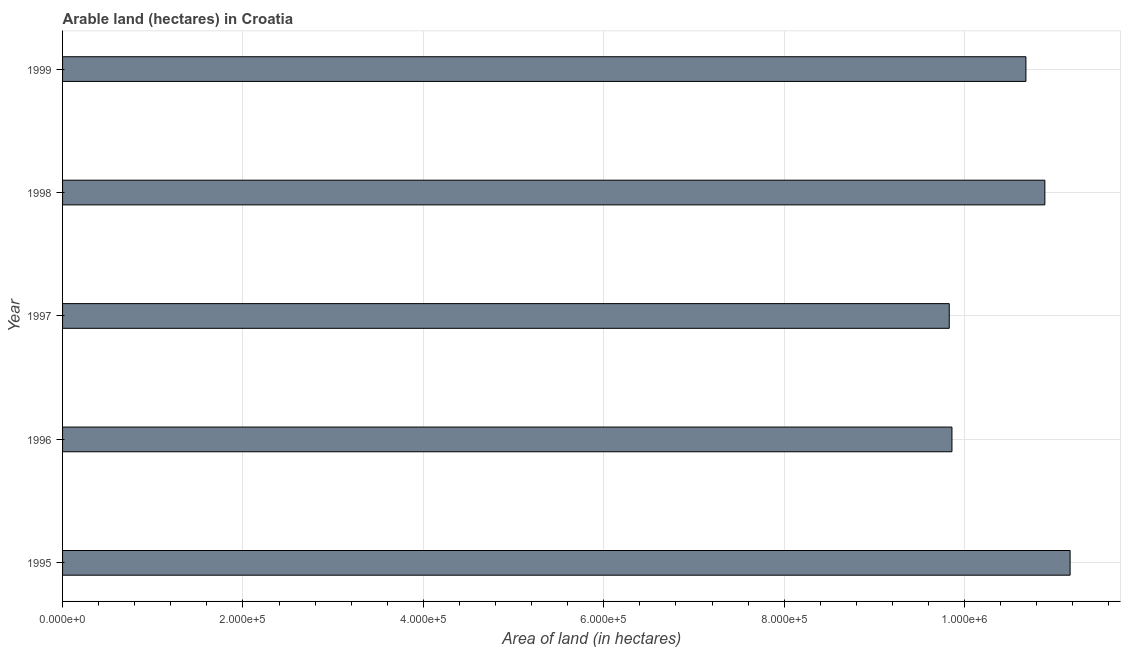What is the title of the graph?
Offer a very short reply. Arable land (hectares) in Croatia. What is the label or title of the X-axis?
Your response must be concise. Area of land (in hectares). What is the label or title of the Y-axis?
Your answer should be compact. Year. What is the area of land in 1995?
Provide a succinct answer. 1.12e+06. Across all years, what is the maximum area of land?
Provide a succinct answer. 1.12e+06. Across all years, what is the minimum area of land?
Give a very brief answer. 9.83e+05. In which year was the area of land maximum?
Your answer should be very brief. 1995. In which year was the area of land minimum?
Offer a very short reply. 1997. What is the sum of the area of land?
Provide a short and direct response. 5.24e+06. What is the difference between the area of land in 1996 and 1998?
Give a very brief answer. -1.03e+05. What is the average area of land per year?
Provide a short and direct response. 1.05e+06. What is the median area of land?
Keep it short and to the point. 1.07e+06. In how many years, is the area of land greater than 760000 hectares?
Provide a succinct answer. 5. What is the ratio of the area of land in 1995 to that in 1999?
Your answer should be compact. 1.05. Is the difference between the area of land in 1995 and 1999 greater than the difference between any two years?
Offer a very short reply. No. What is the difference between the highest and the second highest area of land?
Your response must be concise. 2.80e+04. Is the sum of the area of land in 1997 and 1999 greater than the maximum area of land across all years?
Provide a short and direct response. Yes. What is the difference between the highest and the lowest area of land?
Provide a succinct answer. 1.34e+05. In how many years, is the area of land greater than the average area of land taken over all years?
Offer a very short reply. 3. Are all the bars in the graph horizontal?
Your answer should be compact. Yes. What is the difference between two consecutive major ticks on the X-axis?
Make the answer very short. 2.00e+05. What is the Area of land (in hectares) in 1995?
Ensure brevity in your answer.  1.12e+06. What is the Area of land (in hectares) of 1996?
Provide a short and direct response. 9.86e+05. What is the Area of land (in hectares) of 1997?
Your response must be concise. 9.83e+05. What is the Area of land (in hectares) of 1998?
Your response must be concise. 1.09e+06. What is the Area of land (in hectares) of 1999?
Offer a very short reply. 1.07e+06. What is the difference between the Area of land (in hectares) in 1995 and 1996?
Offer a very short reply. 1.31e+05. What is the difference between the Area of land (in hectares) in 1995 and 1997?
Ensure brevity in your answer.  1.34e+05. What is the difference between the Area of land (in hectares) in 1995 and 1998?
Your answer should be very brief. 2.80e+04. What is the difference between the Area of land (in hectares) in 1995 and 1999?
Your answer should be compact. 4.90e+04. What is the difference between the Area of land (in hectares) in 1996 and 1997?
Ensure brevity in your answer.  3000. What is the difference between the Area of land (in hectares) in 1996 and 1998?
Give a very brief answer. -1.03e+05. What is the difference between the Area of land (in hectares) in 1996 and 1999?
Provide a succinct answer. -8.20e+04. What is the difference between the Area of land (in hectares) in 1997 and 1998?
Your response must be concise. -1.06e+05. What is the difference between the Area of land (in hectares) in 1997 and 1999?
Your answer should be very brief. -8.50e+04. What is the difference between the Area of land (in hectares) in 1998 and 1999?
Provide a short and direct response. 2.10e+04. What is the ratio of the Area of land (in hectares) in 1995 to that in 1996?
Your answer should be compact. 1.13. What is the ratio of the Area of land (in hectares) in 1995 to that in 1997?
Keep it short and to the point. 1.14. What is the ratio of the Area of land (in hectares) in 1995 to that in 1999?
Your answer should be compact. 1.05. What is the ratio of the Area of land (in hectares) in 1996 to that in 1998?
Give a very brief answer. 0.91. What is the ratio of the Area of land (in hectares) in 1996 to that in 1999?
Your answer should be very brief. 0.92. What is the ratio of the Area of land (in hectares) in 1997 to that in 1998?
Your answer should be compact. 0.9. What is the ratio of the Area of land (in hectares) in 1997 to that in 1999?
Ensure brevity in your answer.  0.92. What is the ratio of the Area of land (in hectares) in 1998 to that in 1999?
Offer a terse response. 1.02. 